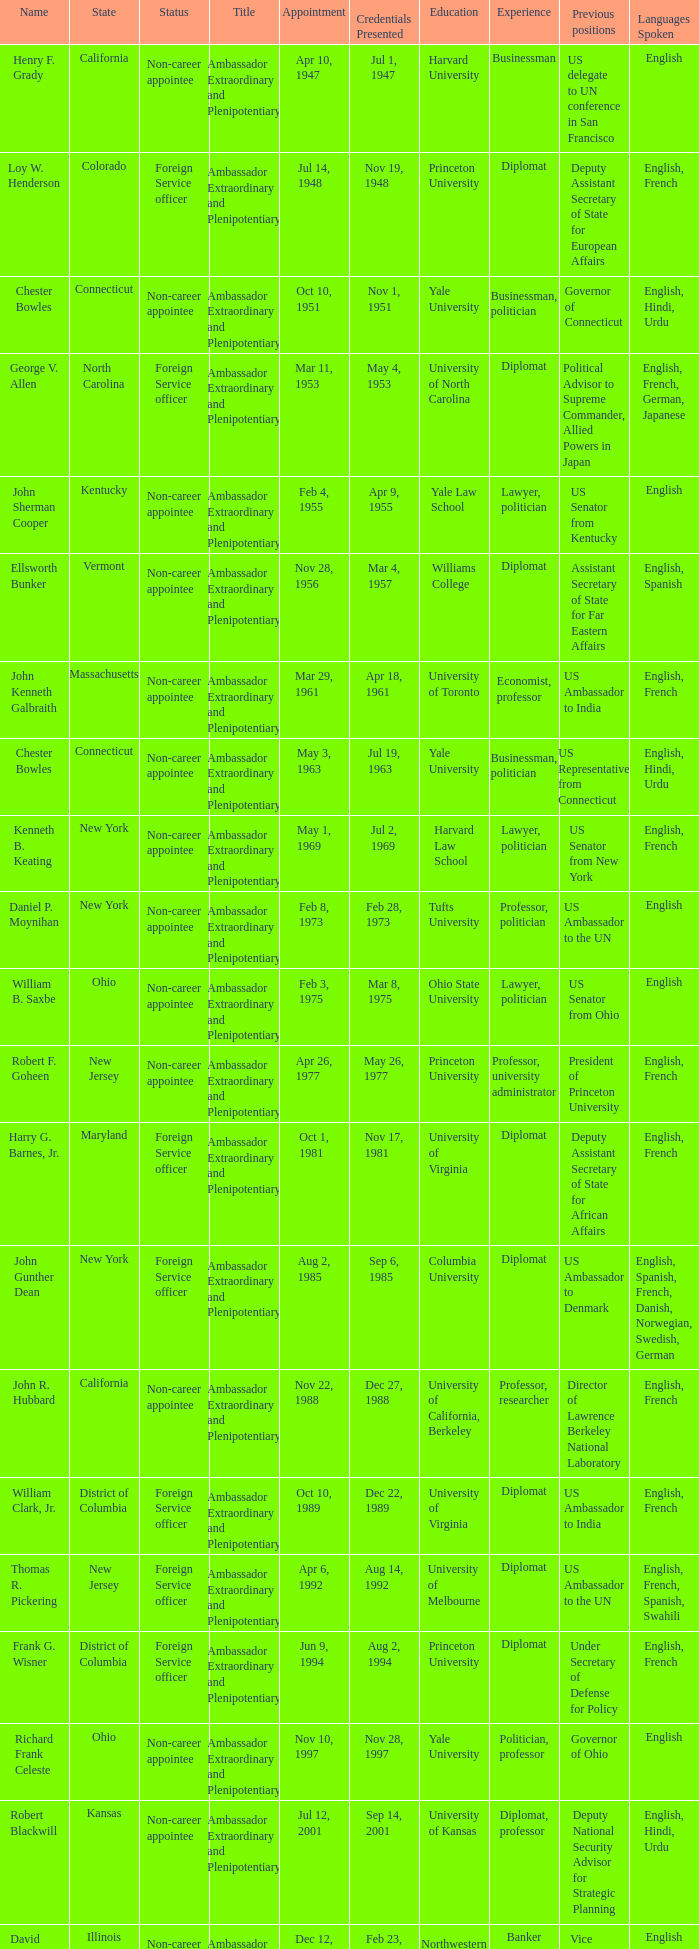What day were credentials presented for vermont? Mar 4, 1957. 